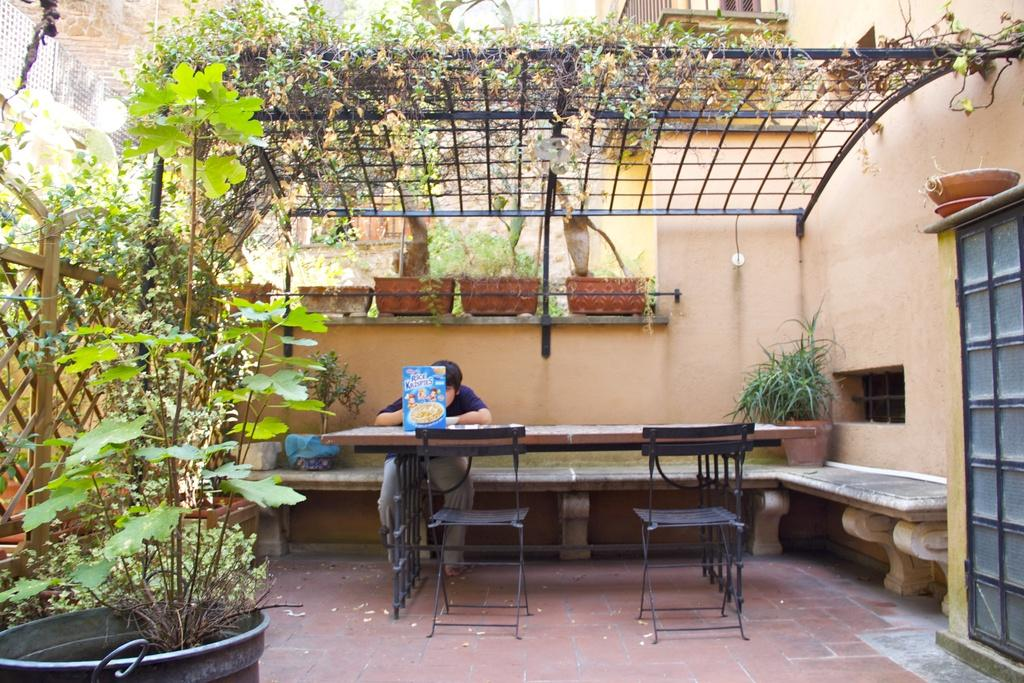What is the person in the image doing? The person is sitting on a chair in the image. What is in front of the person? The person is in front of a table. What type of vegetation is present in the image? There are plants in the image. What type of furniture is visible besides the chair? There is a shelf in the image. How many women are visible in the image? There is no mention of women in the provided facts, so we cannot determine the number of women in the image. 